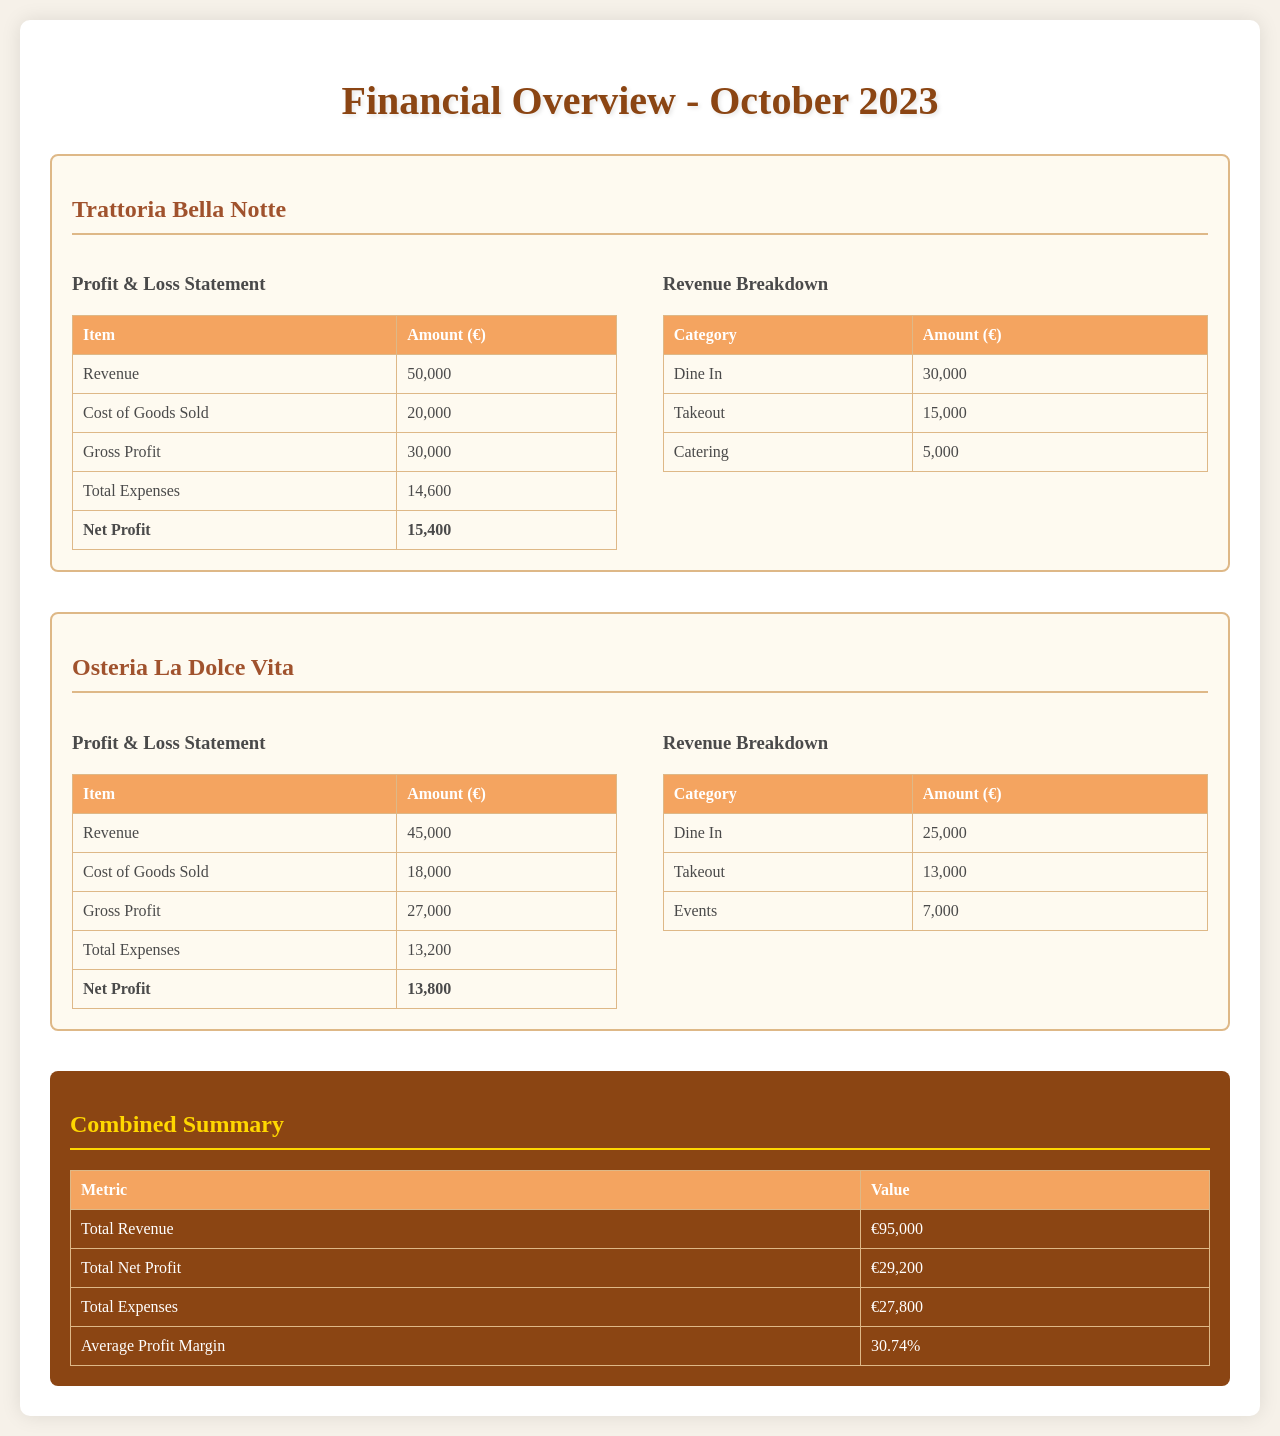What was the total revenue for Trattoria Bella Notte? The total revenue for Trattoria Bella Notte is clearly stated in the document as €50,000.
Answer: €50,000 What are the total expenses for Osteria La Dolce Vita? The total expenses for Osteria La Dolce Vita are listed as €13,200 in the Profit & Loss Statement.
Answer: €13,200 What is the net profit for both restaurants combined? The combined net profit is calculated in the summary section as €29,200.
Answer: €29,200 Which restaurant generated more revenue? A comparison of the revenue figures shows that Trattoria Bella Notte generated €50,000 whereas Osteria La Dolce Vita generated €45,000, making the former higher.
Answer: Trattoria Bella Notte What is the average profit margin for both establishments? The average profit margin is provided in the summary section as 30.74%, derived from total metrics.
Answer: 30.74% How much revenue did Dine In contribute for Osteria La Dolce Vita? The Dine In revenue for Osteria La Dolce Vita is listed as €25,000 in the revenue breakdown.
Answer: €25,000 What was the gross profit for Trattoria Bella Notte? The gross profit for Trattoria Bella Notte is noted as €30,000 in the Profit & Loss Statement.
Answer: €30,000 Which category contributed the least to Trattoria Bella Notte's revenue? The revenue breakdown shows that Catering contributed the least with €5,000.
Answer: Catering What was the cost of goods sold for Osteria La Dolce Vita? The cost of goods sold for Osteria La Dolce Vita is specified as €18,000 in the Profit & Loss Statement.
Answer: €18,000 